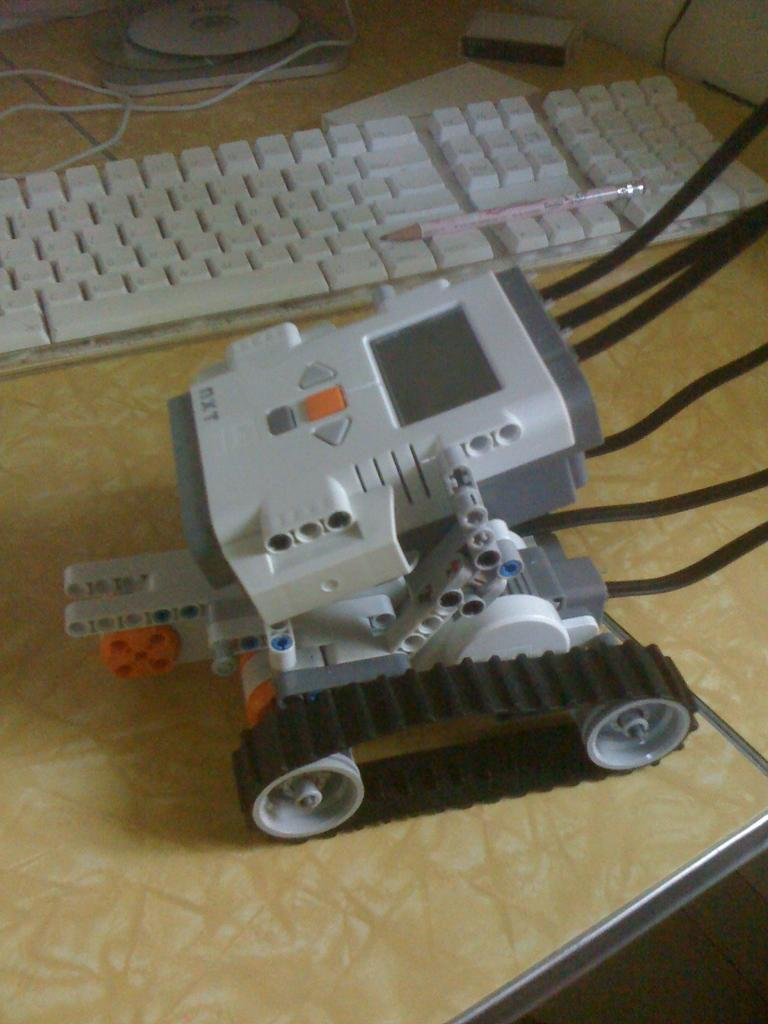What type of vehicle is in the image? There is a robot vehicle in the image. What is placed on the keyboard in the image? There is a pencil on a keyboard in the image. What other objects can be seen on the table in the image? There are other objects on the table in the image, but their specific details are not mentioned in the provided facts. What type of door can be seen in the image? There is no door present in the image. Can you describe the cemetery in the image? There is no cemetery present in the image. 